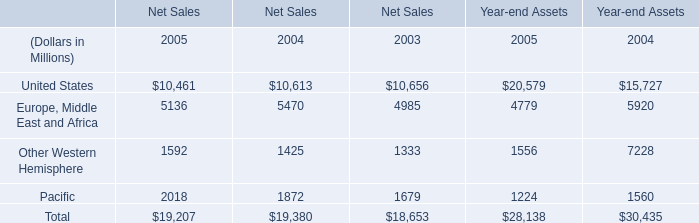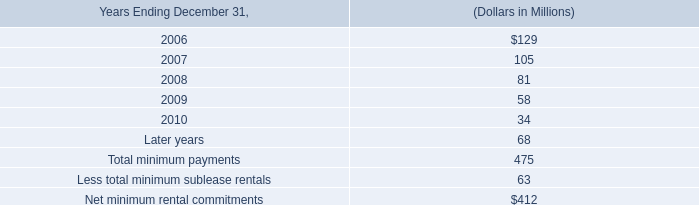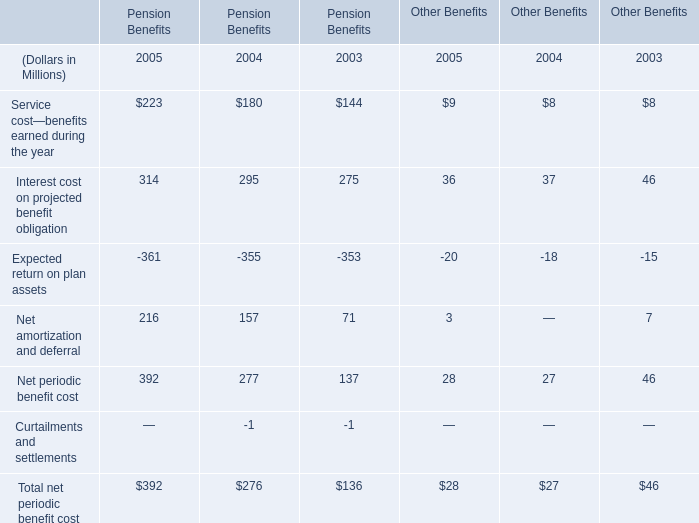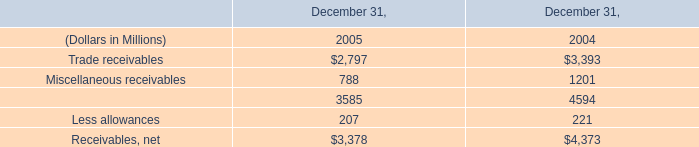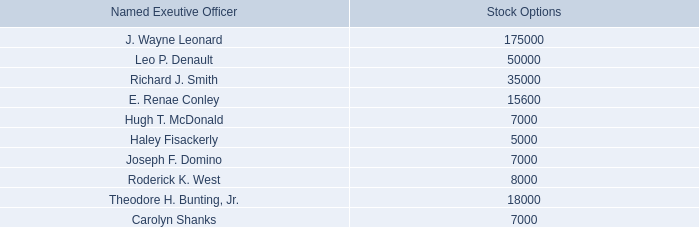What's the sum of Service cost—benefits earned during the year in the range of 1 and 300 in 2005 and 2004 for Pension Benefits (in million) 
Computations: (223 + 180)
Answer: 403.0. 